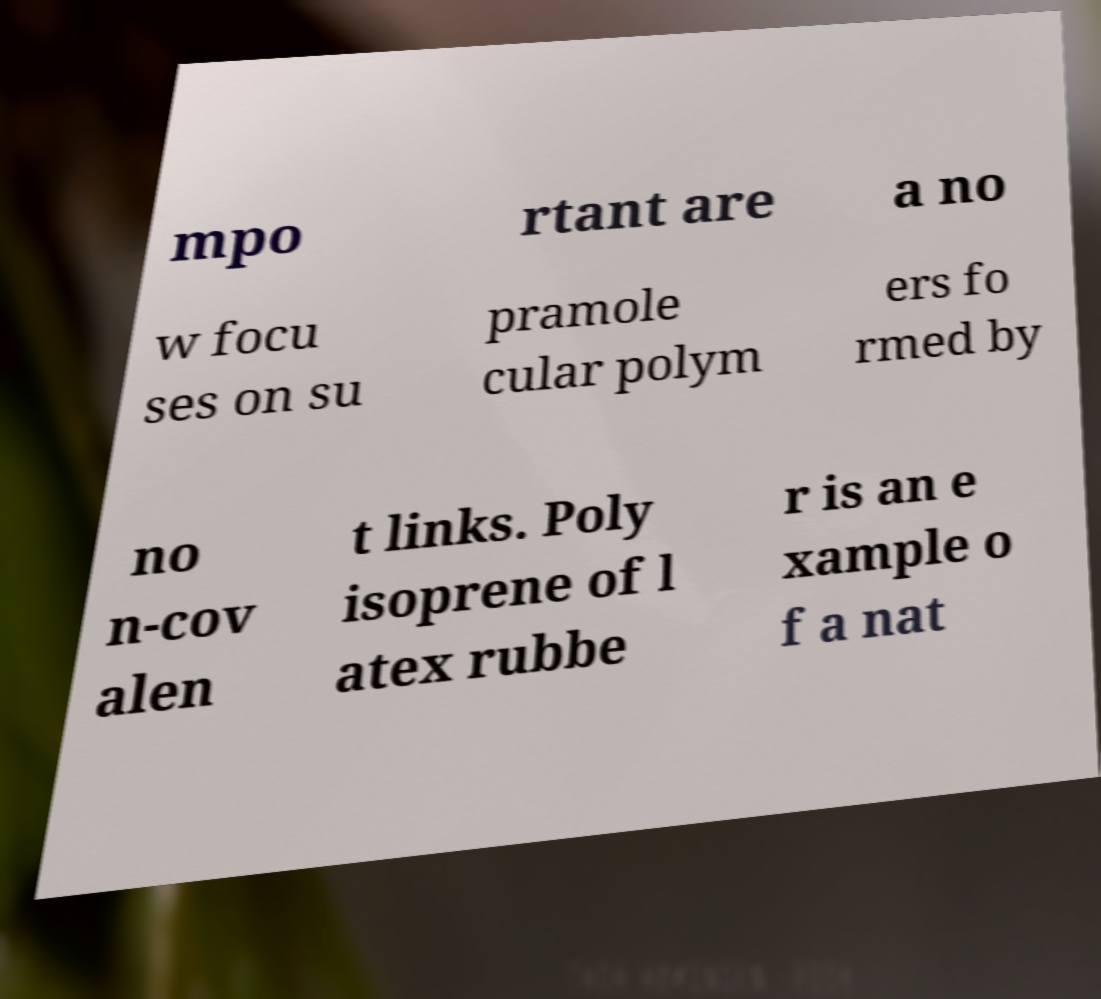Could you assist in decoding the text presented in this image and type it out clearly? mpo rtant are a no w focu ses on su pramole cular polym ers fo rmed by no n-cov alen t links. Poly isoprene of l atex rubbe r is an e xample o f a nat 